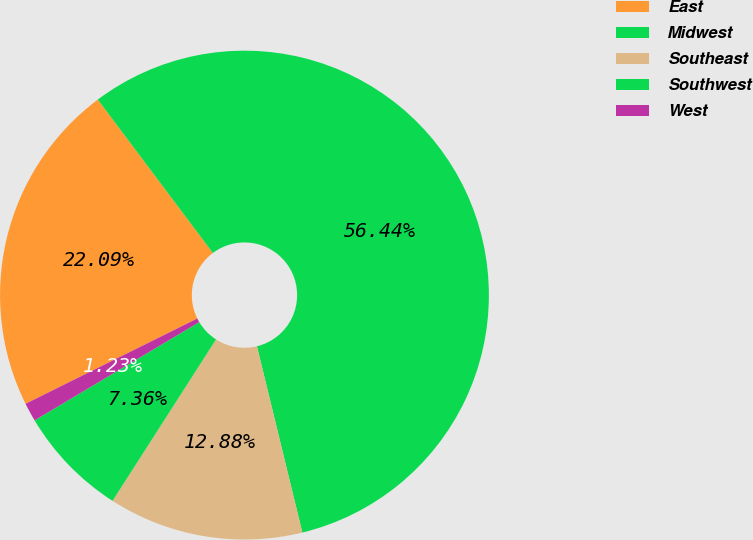Convert chart to OTSL. <chart><loc_0><loc_0><loc_500><loc_500><pie_chart><fcel>East<fcel>Midwest<fcel>Southeast<fcel>Southwest<fcel>West<nl><fcel>22.09%<fcel>56.44%<fcel>12.88%<fcel>7.36%<fcel>1.23%<nl></chart> 